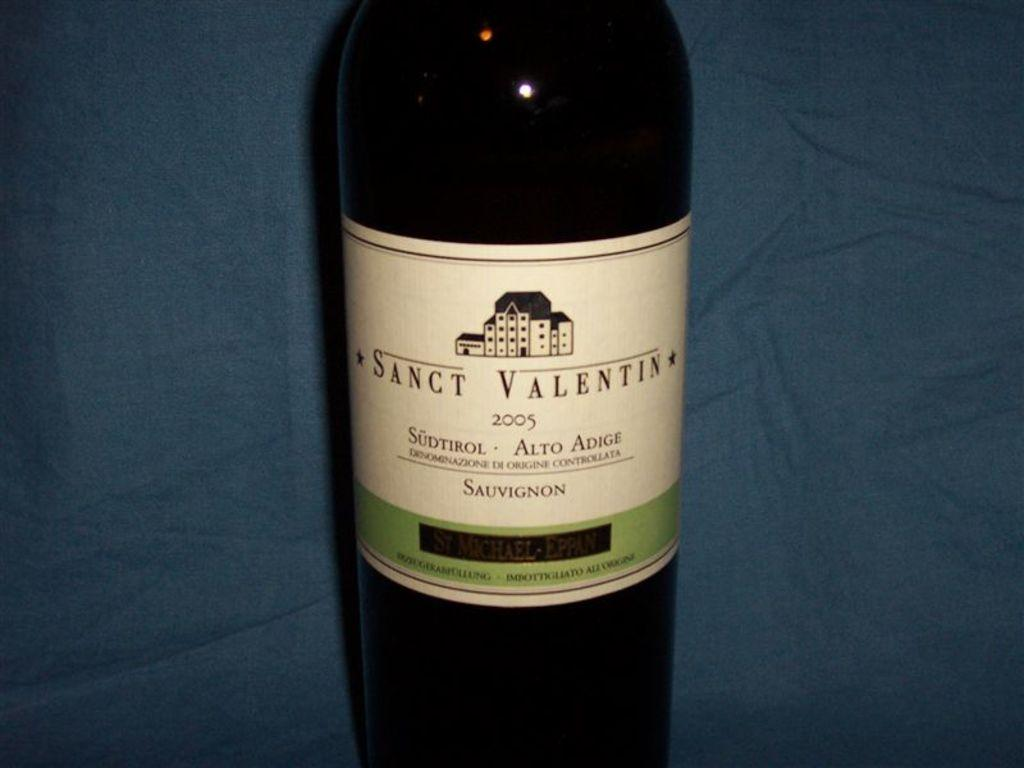<image>
Give a short and clear explanation of the subsequent image. A bottle of Sanct Valentin from 2005 with a white label. 